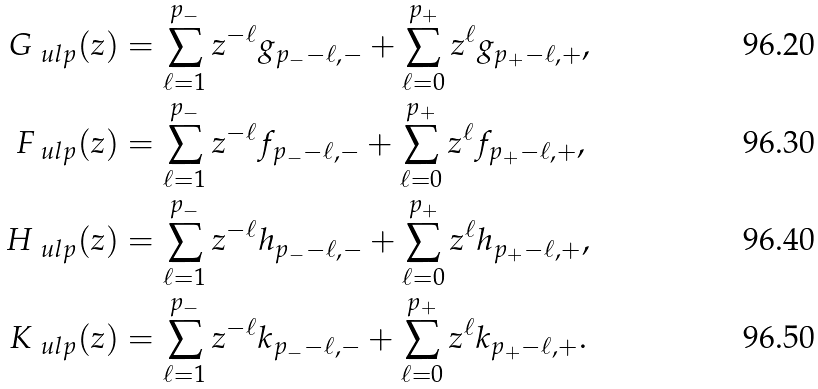Convert formula to latex. <formula><loc_0><loc_0><loc_500><loc_500>G _ { \ u l p } ( z ) & = \sum _ { \ell = 1 } ^ { p _ { - } } z ^ { - \ell } g _ { p _ { - } - \ell , - } + \sum _ { \ell = 0 } ^ { p _ { + } } z ^ { \ell } g _ { p _ { + } - \ell , + } , \\ F _ { \ u l p } ( z ) & = \sum _ { \ell = 1 } ^ { p _ { - } } z ^ { - \ell } f _ { p _ { - } - \ell , - } + \sum _ { \ell = 0 } ^ { p _ { + } } z ^ { \ell } f _ { p _ { + } - \ell , + } , \\ H _ { \ u l p } ( z ) & = \sum _ { \ell = 1 } ^ { p _ { - } } z ^ { - \ell } h _ { p _ { - } - \ell , - } + \sum _ { \ell = 0 } ^ { p _ { + } } z ^ { \ell } h _ { p _ { + } - \ell , + } , \\ K _ { \ u l p } ( z ) & = \sum _ { \ell = 1 } ^ { p _ { - } } z ^ { - \ell } k _ { p _ { - } - \ell , - } + \sum _ { \ell = 0 } ^ { p _ { + } } z ^ { \ell } k _ { p _ { + } - \ell , + } .</formula> 